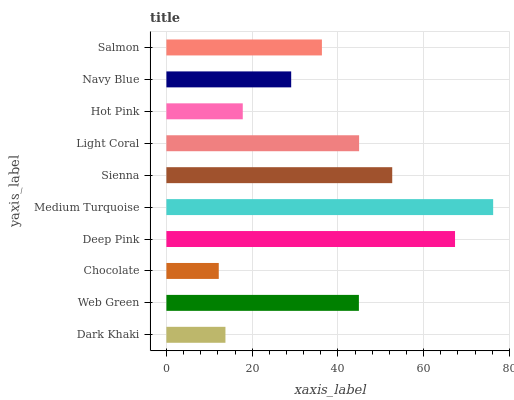Is Chocolate the minimum?
Answer yes or no. Yes. Is Medium Turquoise the maximum?
Answer yes or no. Yes. Is Web Green the minimum?
Answer yes or no. No. Is Web Green the maximum?
Answer yes or no. No. Is Web Green greater than Dark Khaki?
Answer yes or no. Yes. Is Dark Khaki less than Web Green?
Answer yes or no. Yes. Is Dark Khaki greater than Web Green?
Answer yes or no. No. Is Web Green less than Dark Khaki?
Answer yes or no. No. Is Web Green the high median?
Answer yes or no. Yes. Is Salmon the low median?
Answer yes or no. Yes. Is Dark Khaki the high median?
Answer yes or no. No. Is Light Coral the low median?
Answer yes or no. No. 